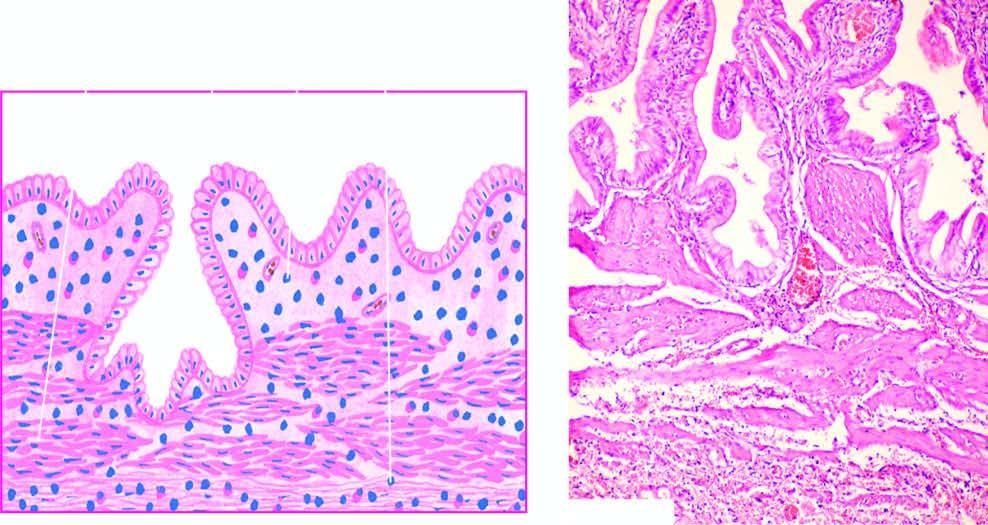s there subepithelial and subserosal fibrosis and hypertrophy of muscularis?
Answer the question using a single word or phrase. Yes 